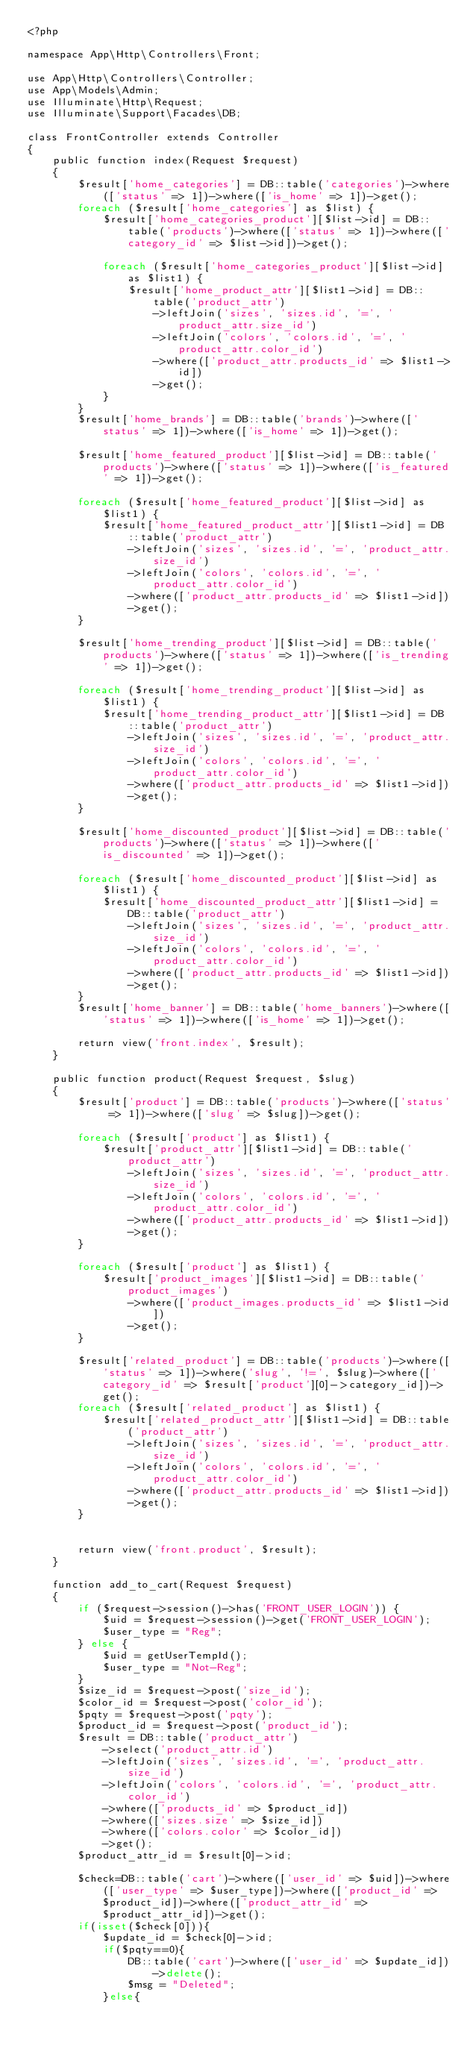Convert code to text. <code><loc_0><loc_0><loc_500><loc_500><_PHP_><?php

namespace App\Http\Controllers\Front;

use App\Http\Controllers\Controller;
use App\Models\Admin;
use Illuminate\Http\Request;
use Illuminate\Support\Facades\DB;

class FrontController extends Controller
{
    public function index(Request $request)
    {
        $result['home_categories'] = DB::table('categories')->where(['status' => 1])->where(['is_home' => 1])->get();
        foreach ($result['home_categories'] as $list) {
            $result['home_categories_product'][$list->id] = DB::table('products')->where(['status' => 1])->where(['category_id' => $list->id])->get();

            foreach ($result['home_categories_product'][$list->id] as $list1) {
                $result['home_product_attr'][$list1->id] = DB::table('product_attr')
                    ->leftJoin('sizes', 'sizes.id', '=', 'product_attr.size_id')
                    ->leftJoin('colors', 'colors.id', '=', 'product_attr.color_id')
                    ->where(['product_attr.products_id' => $list1->id])
                    ->get();
            }
        }
        $result['home_brands'] = DB::table('brands')->where(['status' => 1])->where(['is_home' => 1])->get();

        $result['home_featured_product'][$list->id] = DB::table('products')->where(['status' => 1])->where(['is_featured' => 1])->get();

        foreach ($result['home_featured_product'][$list->id] as $list1) {
            $result['home_featured_product_attr'][$list1->id] = DB::table('product_attr')
                ->leftJoin('sizes', 'sizes.id', '=', 'product_attr.size_id')
                ->leftJoin('colors', 'colors.id', '=', 'product_attr.color_id')
                ->where(['product_attr.products_id' => $list1->id])
                ->get();
        }

        $result['home_trending_product'][$list->id] = DB::table('products')->where(['status' => 1])->where(['is_trending' => 1])->get();

        foreach ($result['home_trending_product'][$list->id] as $list1) {
            $result['home_trending_product_attr'][$list1->id] = DB::table('product_attr')
                ->leftJoin('sizes', 'sizes.id', '=', 'product_attr.size_id')
                ->leftJoin('colors', 'colors.id', '=', 'product_attr.color_id')
                ->where(['product_attr.products_id' => $list1->id])
                ->get();
        }

        $result['home_discounted_product'][$list->id] = DB::table('products')->where(['status' => 1])->where(['is_discounted' => 1])->get();

        foreach ($result['home_discounted_product'][$list->id] as $list1) {
            $result['home_discounted_product_attr'][$list1->id] = DB::table('product_attr')
                ->leftJoin('sizes', 'sizes.id', '=', 'product_attr.size_id')
                ->leftJoin('colors', 'colors.id', '=', 'product_attr.color_id')
                ->where(['product_attr.products_id' => $list1->id])
                ->get();
        }
        $result['home_banner'] = DB::table('home_banners')->where(['status' => 1])->where(['is_home' => 1])->get();

        return view('front.index', $result);
    }

    public function product(Request $request, $slug)
    {
        $result['product'] = DB::table('products')->where(['status' => 1])->where(['slug' => $slug])->get();

        foreach ($result['product'] as $list1) {
            $result['product_attr'][$list1->id] = DB::table('product_attr')
                ->leftJoin('sizes', 'sizes.id', '=', 'product_attr.size_id')
                ->leftJoin('colors', 'colors.id', '=', 'product_attr.color_id')
                ->where(['product_attr.products_id' => $list1->id])
                ->get();
        }

        foreach ($result['product'] as $list1) {
            $result['product_images'][$list1->id] = DB::table('product_images')
                ->where(['product_images.products_id' => $list1->id])
                ->get();
        }

        $result['related_product'] = DB::table('products')->where(['status' => 1])->where('slug', '!=', $slug)->where(['category_id' => $result['product'][0]->category_id])->get();
        foreach ($result['related_product'] as $list1) {
            $result['related_product_attr'][$list1->id] = DB::table('product_attr')
                ->leftJoin('sizes', 'sizes.id', '=', 'product_attr.size_id')
                ->leftJoin('colors', 'colors.id', '=', 'product_attr.color_id')
                ->where(['product_attr.products_id' => $list1->id])
                ->get();
        }


        return view('front.product', $result);
    }

    function add_to_cart(Request $request)
    {
        if ($request->session()->has('FRONT_USER_LOGIN')) {
            $uid = $request->session()->get('FRONT_USER_LOGIN');
            $user_type = "Reg";
        } else {
            $uid = getUserTempId();
            $user_type = "Not-Reg";
        }
        $size_id = $request->post('size_id');
        $color_id = $request->post('color_id');
        $pqty = $request->post('pqty');
        $product_id = $request->post('product_id');
        $result = DB::table('product_attr')
            ->select('product_attr.id')
            ->leftJoin('sizes', 'sizes.id', '=', 'product_attr.size_id')
            ->leftJoin('colors', 'colors.id', '=', 'product_attr.color_id')
            ->where(['products_id' => $product_id])
            ->where(['sizes.size' => $size_id])
            ->where(['colors.color' => $color_id])
            ->get();
        $product_attr_id = $result[0]->id;

        $check=DB::table('cart')->where(['user_id' => $uid])->where(['user_type' => $user_type])->where(['product_id' => $product_id])->where(['product_attr_id' =>$product_attr_id])->get();
        if(isset($check[0])){
            $update_id = $check[0]->id;
            if($pqty==0){
                DB::table('cart')->where(['user_id' => $update_id])->delete();
                $msg = "Deleted";
            }else{</code> 